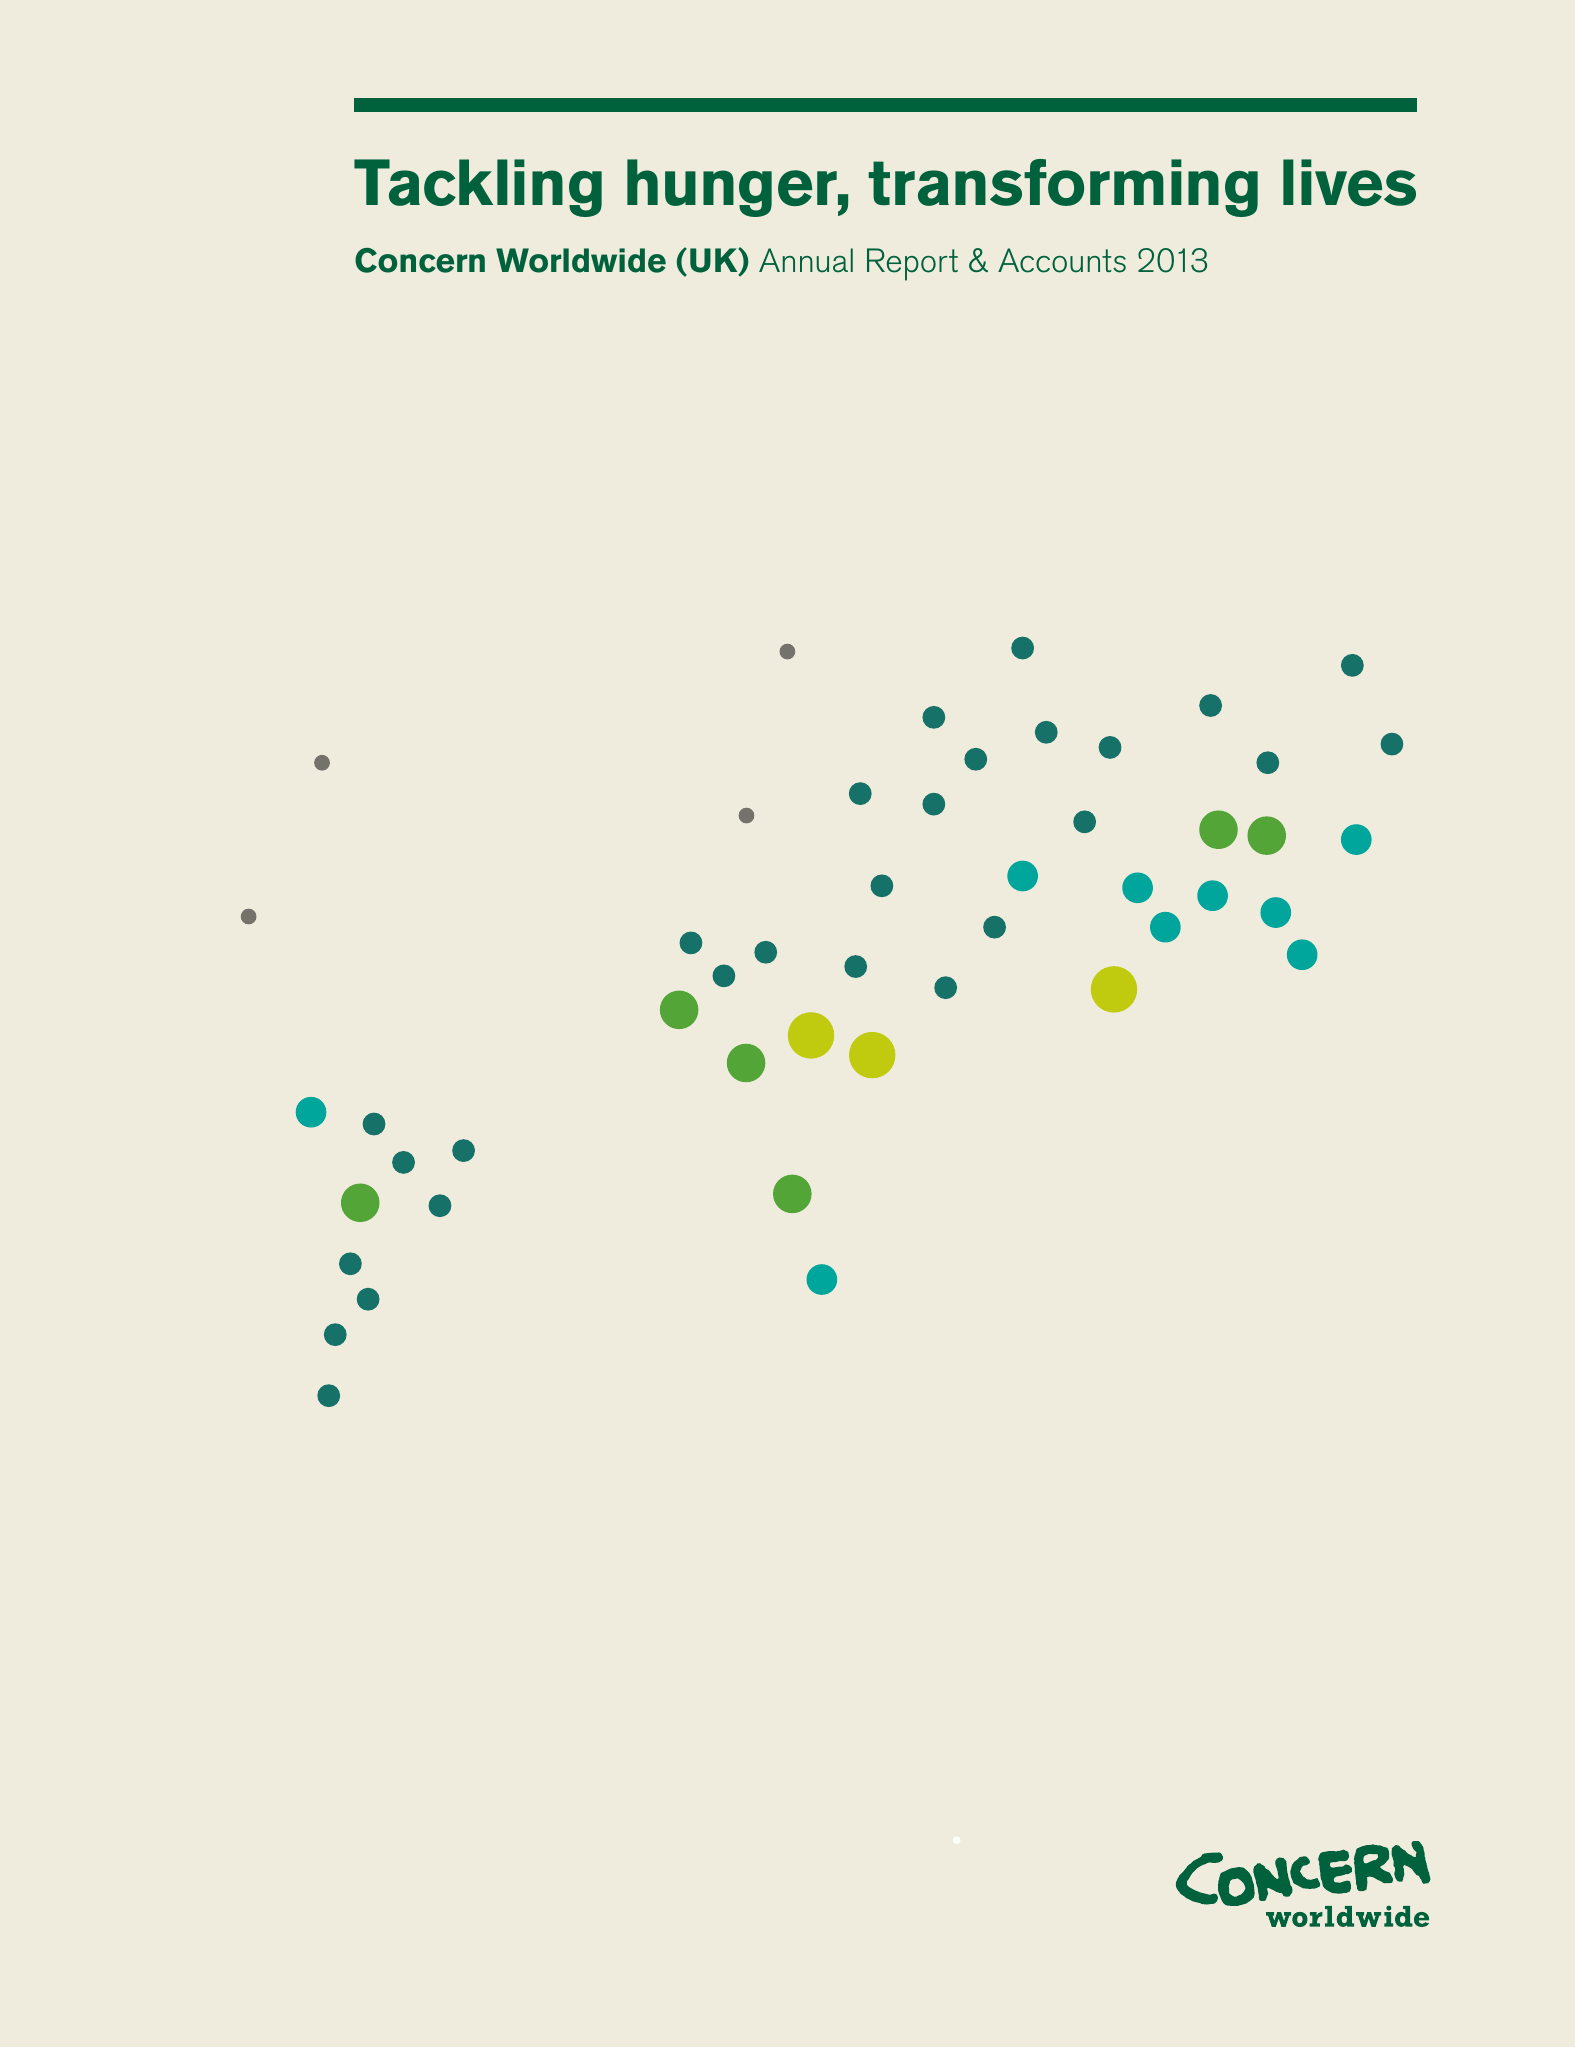What is the value for the address__postcode?
Answer the question using a single word or phrase. SW11 3TN 